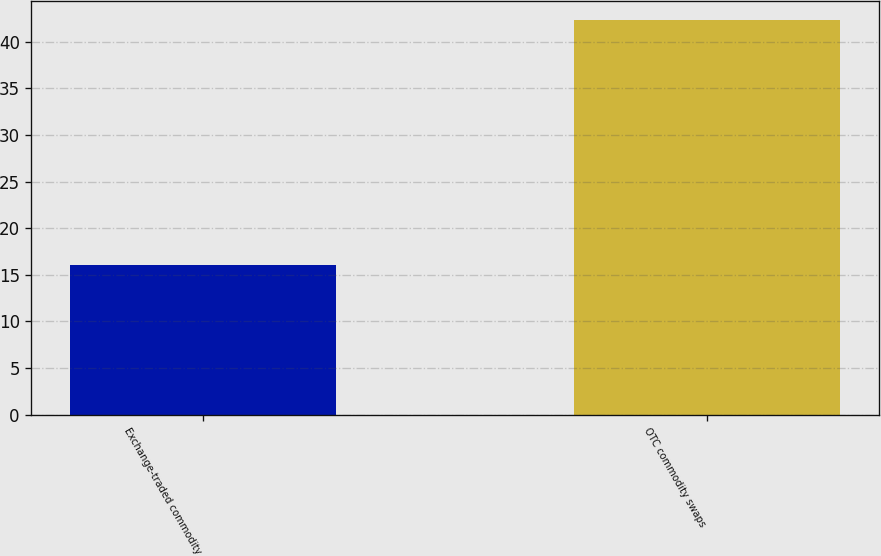Convert chart to OTSL. <chart><loc_0><loc_0><loc_500><loc_500><bar_chart><fcel>Exchange-traded commodity<fcel>OTC commodity swaps<nl><fcel>16<fcel>42.3<nl></chart> 